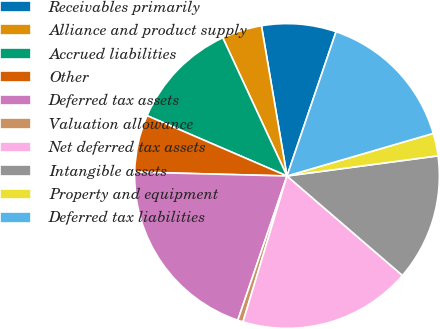Convert chart. <chart><loc_0><loc_0><loc_500><loc_500><pie_chart><fcel>Receivables primarily<fcel>Alliance and product supply<fcel>Accrued liabilities<fcel>Other<fcel>Deferred tax assets<fcel>Valuation allowance<fcel>Net deferred tax assets<fcel>Intangible assets<fcel>Property and equipment<fcel>Deferred tax liabilities<nl><fcel>7.9%<fcel>4.24%<fcel>11.6%<fcel>6.07%<fcel>20.18%<fcel>0.57%<fcel>18.34%<fcel>13.43%<fcel>2.4%<fcel>15.27%<nl></chart> 